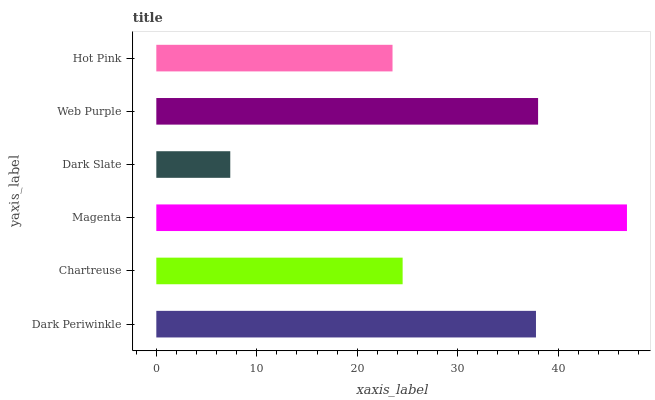Is Dark Slate the minimum?
Answer yes or no. Yes. Is Magenta the maximum?
Answer yes or no. Yes. Is Chartreuse the minimum?
Answer yes or no. No. Is Chartreuse the maximum?
Answer yes or no. No. Is Dark Periwinkle greater than Chartreuse?
Answer yes or no. Yes. Is Chartreuse less than Dark Periwinkle?
Answer yes or no. Yes. Is Chartreuse greater than Dark Periwinkle?
Answer yes or no. No. Is Dark Periwinkle less than Chartreuse?
Answer yes or no. No. Is Dark Periwinkle the high median?
Answer yes or no. Yes. Is Chartreuse the low median?
Answer yes or no. Yes. Is Dark Slate the high median?
Answer yes or no. No. Is Dark Slate the low median?
Answer yes or no. No. 